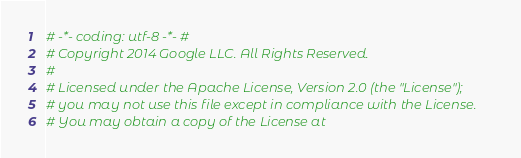Convert code to text. <code><loc_0><loc_0><loc_500><loc_500><_Python_># -*- coding: utf-8 -*- #
# Copyright 2014 Google LLC. All Rights Reserved.
#
# Licensed under the Apache License, Version 2.0 (the "License");
# you may not use this file except in compliance with the License.
# You may obtain a copy of the License at</code> 